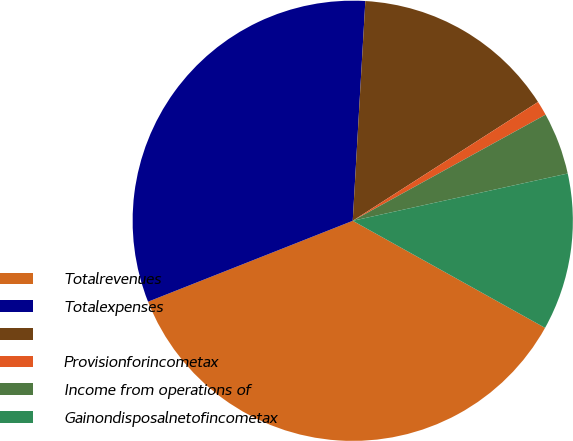Convert chart. <chart><loc_0><loc_0><loc_500><loc_500><pie_chart><fcel>Totalrevenues<fcel>Totalexpenses<fcel>Unnamed: 2<fcel>Provisionforincometax<fcel>Income from operations of<fcel>Gainondisposalnetofincometax<nl><fcel>35.92%<fcel>31.9%<fcel>15.01%<fcel>1.07%<fcel>4.56%<fcel>11.53%<nl></chart> 